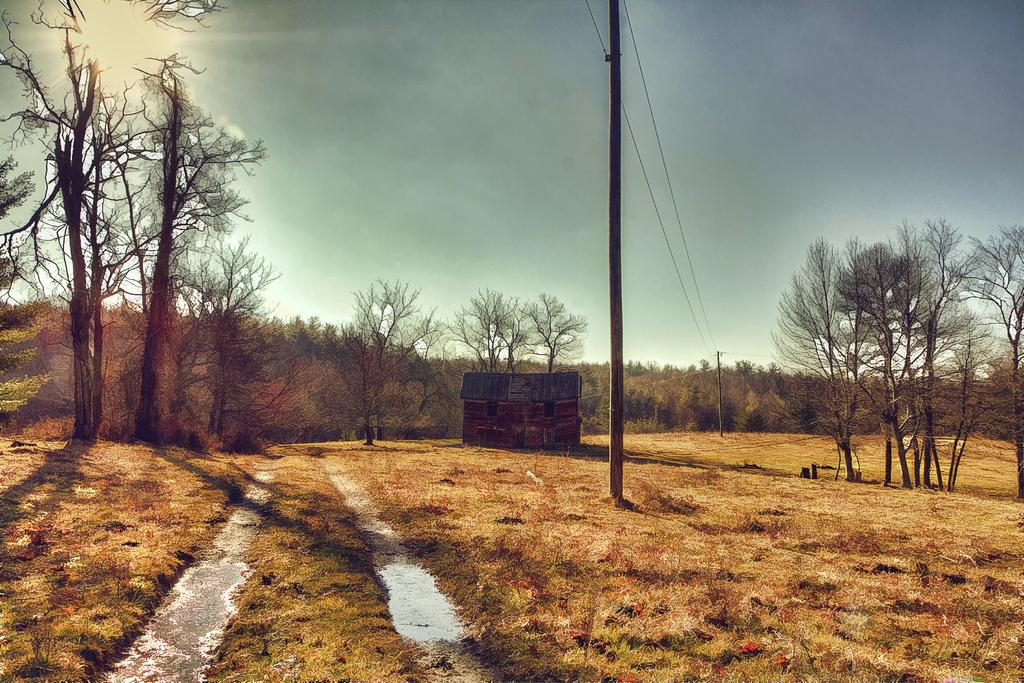What structures can be seen in the image? There are electric poles and a house in the image. What can be found in the background of the image? There are dried trees and green trees in the background of the image. How would you describe the sky in the image? The sky is a combination of white and blue colors. What type of soup is being served in the image? There is no soup present in the image; it features electric poles, a house, trees, and a sky. What is the texture of the train in the image? There is no train present in the image. 